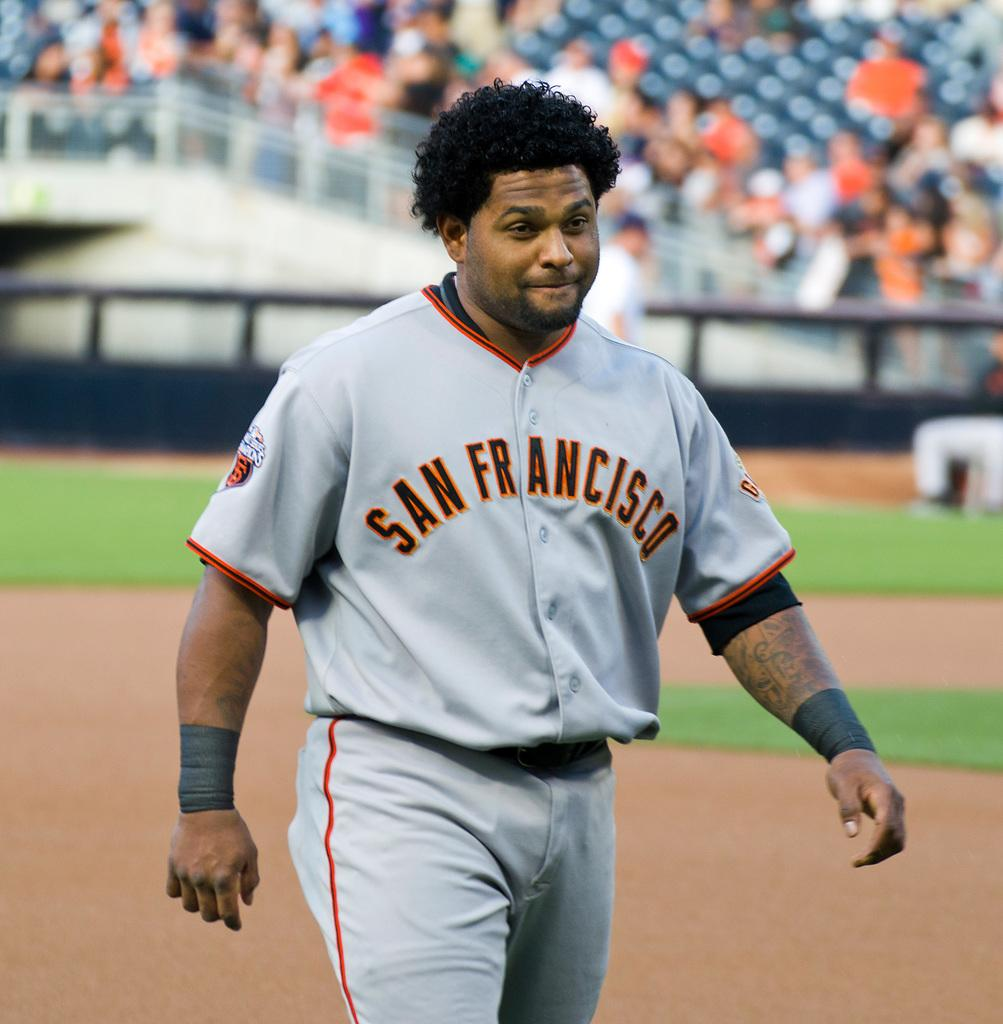What is the main subject of the image? There is a person in the image. What type of brass instrument is the person playing in the image? There is no brass instrument present in the image, as the only fact provided is that there is a person in the image. 